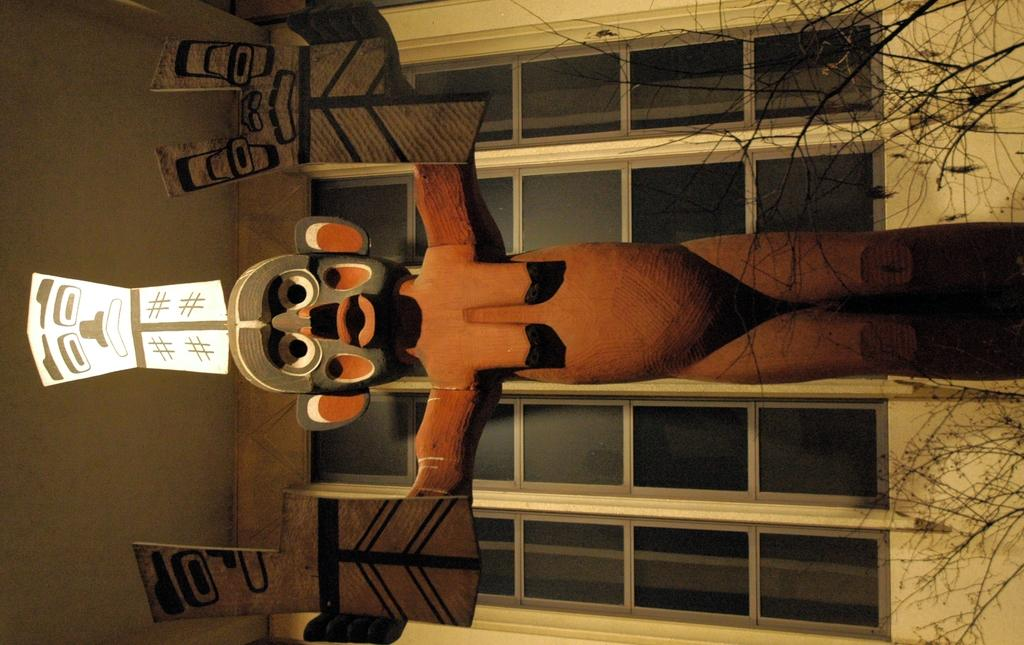What is the main subject in the foreground of the image? There is a sculpture in the foreground of the image. What can be seen behind the sculpture? There is a window behind the sculpture. What type of vegetation is on the right side of the image? There are stems without leaves on the right side of the image. What part of the room can be seen on the left side of the image? The ceiling is visible on the left side of the image. Can you tell me how many carts are in the image? There are no carts present in the image. How does the wheel interact with the sculpture in the image? There is: There is no wheel present in the image; it only features a sculpture, a window, stems without leaves, and the ceiling. 